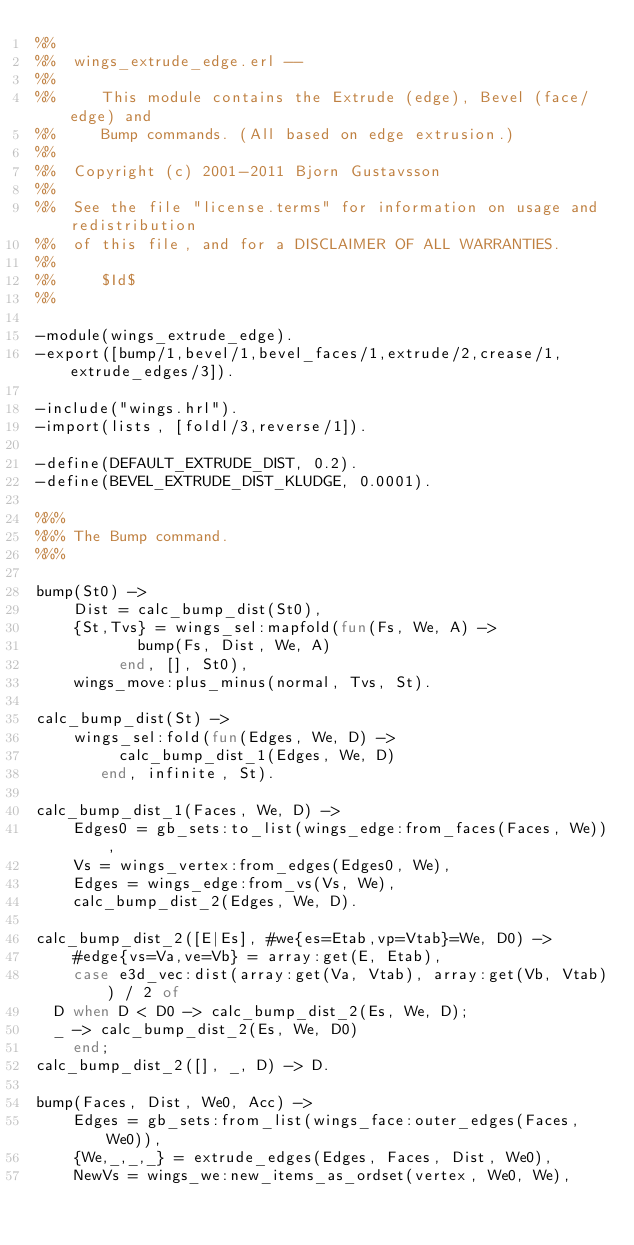<code> <loc_0><loc_0><loc_500><loc_500><_Erlang_>%%
%%  wings_extrude_edge.erl --
%%
%%     This module contains the Extrude (edge), Bevel (face/edge) and
%%     Bump commands. (All based on edge extrusion.)
%%
%%  Copyright (c) 2001-2011 Bjorn Gustavsson
%%
%%  See the file "license.terms" for information on usage and redistribution
%%  of this file, and for a DISCLAIMER OF ALL WARRANTIES.
%%
%%     $Id$
%%

-module(wings_extrude_edge).
-export([bump/1,bevel/1,bevel_faces/1,extrude/2,crease/1,extrude_edges/3]).

-include("wings.hrl").
-import(lists, [foldl/3,reverse/1]).

-define(DEFAULT_EXTRUDE_DIST, 0.2).
-define(BEVEL_EXTRUDE_DIST_KLUDGE, 0.0001).

%%%
%%% The Bump command.
%%%

bump(St0) ->
    Dist = calc_bump_dist(St0),
    {St,Tvs} = wings_sel:mapfold(fun(Fs, We, A) ->
					 bump(Fs, Dist, We, A)
				 end, [], St0),
    wings_move:plus_minus(normal, Tvs, St).

calc_bump_dist(St) ->
    wings_sel:fold(fun(Edges, We, D) ->
			   calc_bump_dist_1(Edges, We, D)
		   end, infinite, St).

calc_bump_dist_1(Faces, We, D) ->
    Edges0 = gb_sets:to_list(wings_edge:from_faces(Faces, We)),
    Vs = wings_vertex:from_edges(Edges0, We),
    Edges = wings_edge:from_vs(Vs, We),
    calc_bump_dist_2(Edges, We, D).

calc_bump_dist_2([E|Es], #we{es=Etab,vp=Vtab}=We, D0) ->
    #edge{vs=Va,ve=Vb} = array:get(E, Etab),
    case e3d_vec:dist(array:get(Va, Vtab), array:get(Vb, Vtab)) / 2 of
	D when D < D0 -> calc_bump_dist_2(Es, We, D);
	_ -> calc_bump_dist_2(Es, We, D0)
    end;
calc_bump_dist_2([], _, D) -> D.

bump(Faces, Dist, We0, Acc) ->
    Edges = gb_sets:from_list(wings_face:outer_edges(Faces, We0)),
    {We,_,_,_} = extrude_edges(Edges, Faces, Dist, We0),
    NewVs = wings_we:new_items_as_ordset(vertex, We0, We),</code> 